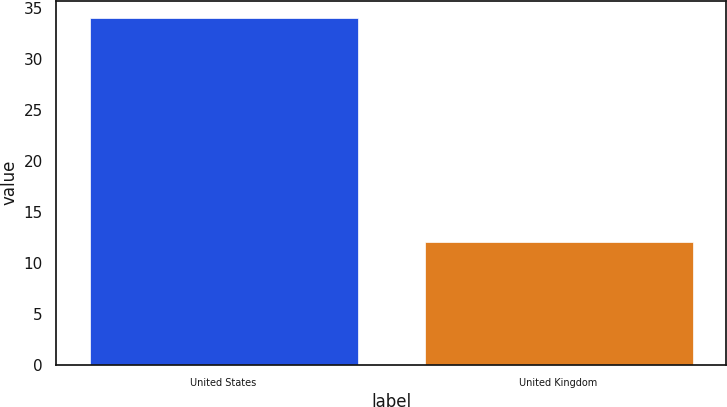Convert chart to OTSL. <chart><loc_0><loc_0><loc_500><loc_500><bar_chart><fcel>United States<fcel>United Kingdom<nl><fcel>34<fcel>12<nl></chart> 